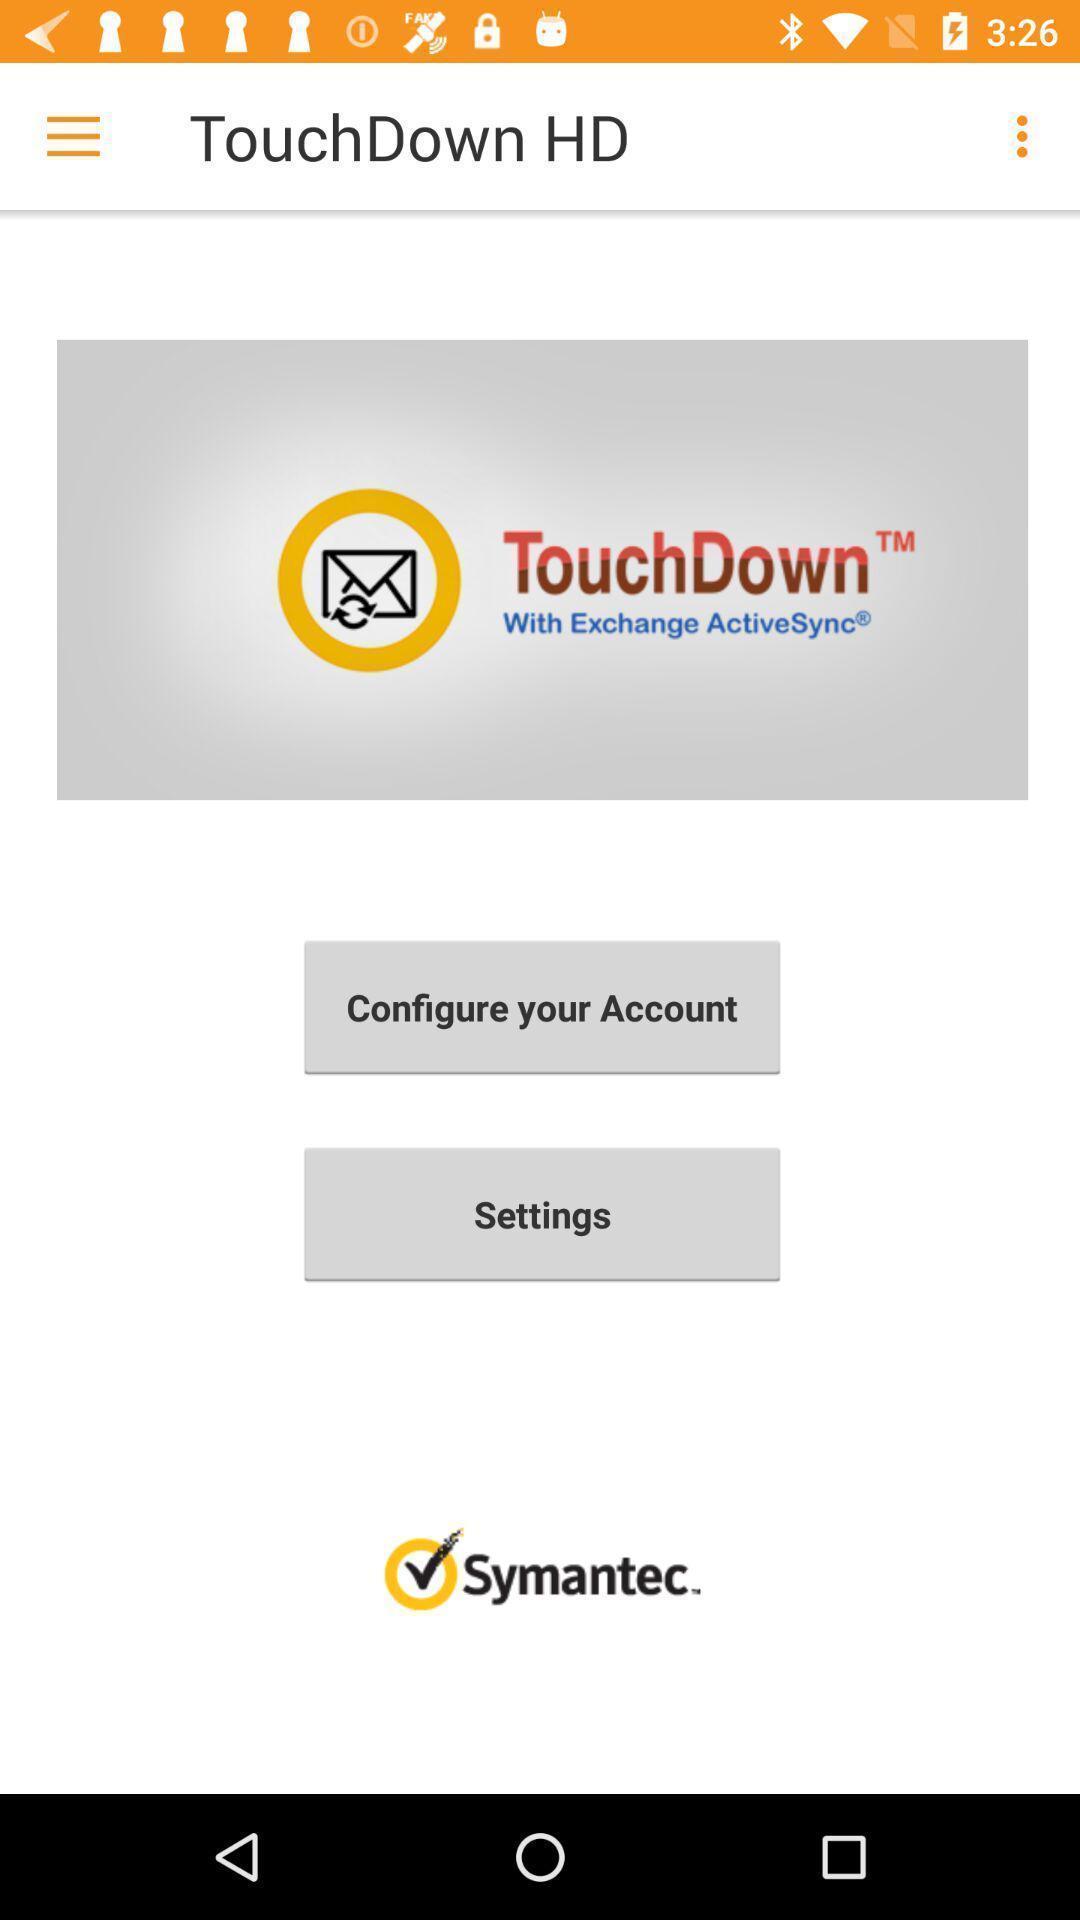Describe the visual elements of this screenshot. Screen displaying options to activate account for an application. 